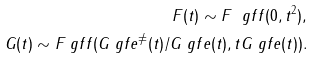<formula> <loc_0><loc_0><loc_500><loc_500>F ( t ) \sim F _ { \ } g f f ( 0 , t ^ { 2 } ) , \\ G ( t ) \sim F _ { \ } g f f ( G _ { \ } g f e ^ { \neq } ( t ) / G _ { \ } g f e ( t ) , t G _ { \ } g f e ( t ) ) .</formula> 